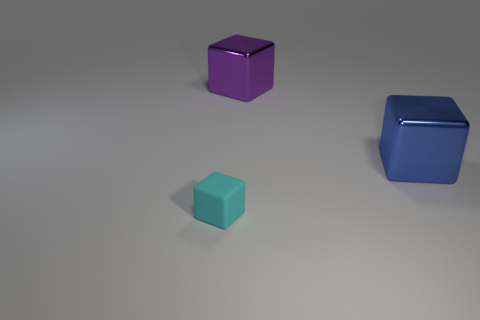Can you guess the potential size of these objects in relation to each other? Although there's no reference object for exact scale, the objects seem to be of similar size categories with the central object being the smallest. Their relative sizes could range from a few centimeters to several inches based on typical object proportions. 